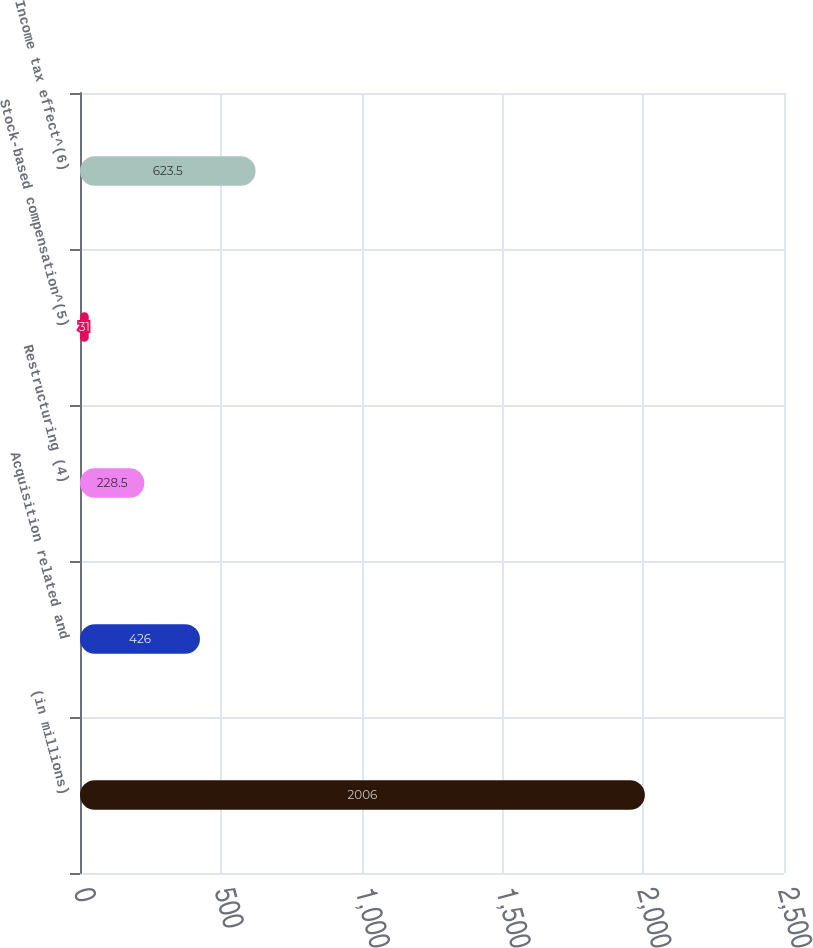<chart> <loc_0><loc_0><loc_500><loc_500><bar_chart><fcel>(in millions)<fcel>Acquisition related and<fcel>Restructuring (4)<fcel>Stock-based compensation^(5)<fcel>Income tax effect^(6)<nl><fcel>2006<fcel>426<fcel>228.5<fcel>31<fcel>623.5<nl></chart> 